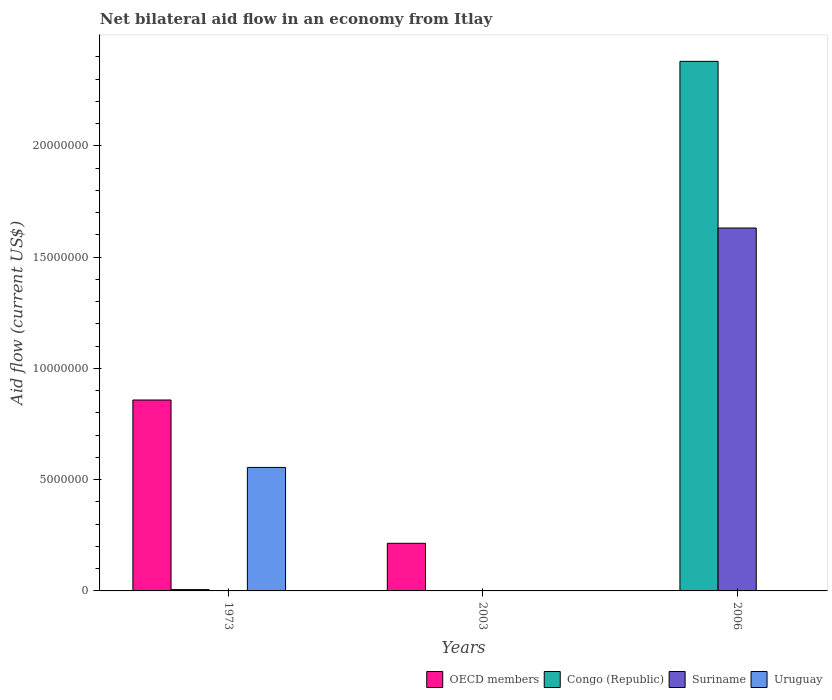Are the number of bars per tick equal to the number of legend labels?
Your answer should be very brief. No. What is the net bilateral aid flow in OECD members in 2006?
Ensure brevity in your answer.  0. Across all years, what is the maximum net bilateral aid flow in Uruguay?
Provide a succinct answer. 5.55e+06. What is the total net bilateral aid flow in Uruguay in the graph?
Provide a short and direct response. 5.55e+06. What is the difference between the net bilateral aid flow in Suriname in 1973 and that in 2006?
Keep it short and to the point. -1.63e+07. What is the difference between the net bilateral aid flow in OECD members in 1973 and the net bilateral aid flow in Congo (Republic) in 2006?
Offer a terse response. -1.52e+07. What is the average net bilateral aid flow in Uruguay per year?
Keep it short and to the point. 1.85e+06. In the year 1973, what is the difference between the net bilateral aid flow in Congo (Republic) and net bilateral aid flow in OECD members?
Offer a very short reply. -8.52e+06. What is the ratio of the net bilateral aid flow in Congo (Republic) in 1973 to that in 2006?
Give a very brief answer. 0. Is the net bilateral aid flow in Congo (Republic) in 1973 less than that in 2006?
Offer a terse response. Yes. What is the difference between the highest and the second highest net bilateral aid flow in Suriname?
Provide a succinct answer. 1.63e+07. What is the difference between the highest and the lowest net bilateral aid flow in Uruguay?
Offer a terse response. 5.55e+06. Is the sum of the net bilateral aid flow in Suriname in 2003 and 2006 greater than the maximum net bilateral aid flow in Congo (Republic) across all years?
Give a very brief answer. No. How many bars are there?
Make the answer very short. 8. Are all the bars in the graph horizontal?
Ensure brevity in your answer.  No. How many years are there in the graph?
Make the answer very short. 3. What is the difference between two consecutive major ticks on the Y-axis?
Your answer should be very brief. 5.00e+06. Are the values on the major ticks of Y-axis written in scientific E-notation?
Provide a succinct answer. No. Does the graph contain any zero values?
Provide a succinct answer. Yes. How many legend labels are there?
Ensure brevity in your answer.  4. How are the legend labels stacked?
Ensure brevity in your answer.  Horizontal. What is the title of the graph?
Give a very brief answer. Net bilateral aid flow in an economy from Itlay. Does "Cote d'Ivoire" appear as one of the legend labels in the graph?
Offer a very short reply. No. What is the Aid flow (current US$) of OECD members in 1973?
Provide a short and direct response. 8.58e+06. What is the Aid flow (current US$) of Uruguay in 1973?
Provide a short and direct response. 5.55e+06. What is the Aid flow (current US$) of OECD members in 2003?
Ensure brevity in your answer.  2.14e+06. What is the Aid flow (current US$) of Congo (Republic) in 2003?
Your answer should be compact. 0. What is the Aid flow (current US$) in Uruguay in 2003?
Ensure brevity in your answer.  0. What is the Aid flow (current US$) of Congo (Republic) in 2006?
Your answer should be compact. 2.38e+07. What is the Aid flow (current US$) of Suriname in 2006?
Make the answer very short. 1.63e+07. What is the Aid flow (current US$) of Uruguay in 2006?
Ensure brevity in your answer.  0. Across all years, what is the maximum Aid flow (current US$) of OECD members?
Your answer should be very brief. 8.58e+06. Across all years, what is the maximum Aid flow (current US$) of Congo (Republic)?
Make the answer very short. 2.38e+07. Across all years, what is the maximum Aid flow (current US$) in Suriname?
Make the answer very short. 1.63e+07. Across all years, what is the maximum Aid flow (current US$) of Uruguay?
Your response must be concise. 5.55e+06. Across all years, what is the minimum Aid flow (current US$) of OECD members?
Give a very brief answer. 0. Across all years, what is the minimum Aid flow (current US$) of Suriname?
Provide a short and direct response. 10000. What is the total Aid flow (current US$) in OECD members in the graph?
Make the answer very short. 1.07e+07. What is the total Aid flow (current US$) in Congo (Republic) in the graph?
Ensure brevity in your answer.  2.39e+07. What is the total Aid flow (current US$) in Suriname in the graph?
Make the answer very short. 1.63e+07. What is the total Aid flow (current US$) of Uruguay in the graph?
Provide a short and direct response. 5.55e+06. What is the difference between the Aid flow (current US$) of OECD members in 1973 and that in 2003?
Your response must be concise. 6.44e+06. What is the difference between the Aid flow (current US$) of Suriname in 1973 and that in 2003?
Keep it short and to the point. 0. What is the difference between the Aid flow (current US$) of Congo (Republic) in 1973 and that in 2006?
Offer a very short reply. -2.37e+07. What is the difference between the Aid flow (current US$) in Suriname in 1973 and that in 2006?
Keep it short and to the point. -1.63e+07. What is the difference between the Aid flow (current US$) in Suriname in 2003 and that in 2006?
Provide a short and direct response. -1.63e+07. What is the difference between the Aid flow (current US$) in OECD members in 1973 and the Aid flow (current US$) in Suriname in 2003?
Provide a short and direct response. 8.57e+06. What is the difference between the Aid flow (current US$) in OECD members in 1973 and the Aid flow (current US$) in Congo (Republic) in 2006?
Provide a short and direct response. -1.52e+07. What is the difference between the Aid flow (current US$) of OECD members in 1973 and the Aid flow (current US$) of Suriname in 2006?
Offer a very short reply. -7.73e+06. What is the difference between the Aid flow (current US$) in Congo (Republic) in 1973 and the Aid flow (current US$) in Suriname in 2006?
Keep it short and to the point. -1.62e+07. What is the difference between the Aid flow (current US$) of OECD members in 2003 and the Aid flow (current US$) of Congo (Republic) in 2006?
Offer a terse response. -2.17e+07. What is the difference between the Aid flow (current US$) in OECD members in 2003 and the Aid flow (current US$) in Suriname in 2006?
Your response must be concise. -1.42e+07. What is the average Aid flow (current US$) of OECD members per year?
Keep it short and to the point. 3.57e+06. What is the average Aid flow (current US$) in Congo (Republic) per year?
Your answer should be very brief. 7.95e+06. What is the average Aid flow (current US$) in Suriname per year?
Offer a very short reply. 5.44e+06. What is the average Aid flow (current US$) of Uruguay per year?
Make the answer very short. 1.85e+06. In the year 1973, what is the difference between the Aid flow (current US$) in OECD members and Aid flow (current US$) in Congo (Republic)?
Offer a very short reply. 8.52e+06. In the year 1973, what is the difference between the Aid flow (current US$) in OECD members and Aid flow (current US$) in Suriname?
Your answer should be very brief. 8.57e+06. In the year 1973, what is the difference between the Aid flow (current US$) of OECD members and Aid flow (current US$) of Uruguay?
Keep it short and to the point. 3.03e+06. In the year 1973, what is the difference between the Aid flow (current US$) in Congo (Republic) and Aid flow (current US$) in Uruguay?
Your response must be concise. -5.49e+06. In the year 1973, what is the difference between the Aid flow (current US$) in Suriname and Aid flow (current US$) in Uruguay?
Offer a very short reply. -5.54e+06. In the year 2003, what is the difference between the Aid flow (current US$) of OECD members and Aid flow (current US$) of Suriname?
Keep it short and to the point. 2.13e+06. In the year 2006, what is the difference between the Aid flow (current US$) in Congo (Republic) and Aid flow (current US$) in Suriname?
Provide a succinct answer. 7.49e+06. What is the ratio of the Aid flow (current US$) of OECD members in 1973 to that in 2003?
Offer a terse response. 4.01. What is the ratio of the Aid flow (current US$) in Suriname in 1973 to that in 2003?
Your response must be concise. 1. What is the ratio of the Aid flow (current US$) of Congo (Republic) in 1973 to that in 2006?
Offer a terse response. 0. What is the ratio of the Aid flow (current US$) in Suriname in 1973 to that in 2006?
Make the answer very short. 0. What is the ratio of the Aid flow (current US$) of Suriname in 2003 to that in 2006?
Provide a short and direct response. 0. What is the difference between the highest and the second highest Aid flow (current US$) in Suriname?
Provide a succinct answer. 1.63e+07. What is the difference between the highest and the lowest Aid flow (current US$) in OECD members?
Offer a very short reply. 8.58e+06. What is the difference between the highest and the lowest Aid flow (current US$) in Congo (Republic)?
Make the answer very short. 2.38e+07. What is the difference between the highest and the lowest Aid flow (current US$) of Suriname?
Keep it short and to the point. 1.63e+07. What is the difference between the highest and the lowest Aid flow (current US$) in Uruguay?
Keep it short and to the point. 5.55e+06. 